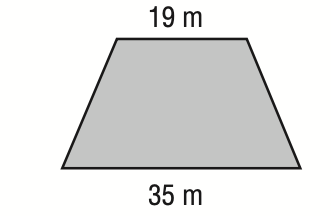Question: The lengths of the bases of an isosceles trapezoid are shown below. If the perimeter is 74 meters, what is its area?
Choices:
A. 162
B. 270
C. 332.5
D. 342.25
Answer with the letter. Answer: A 